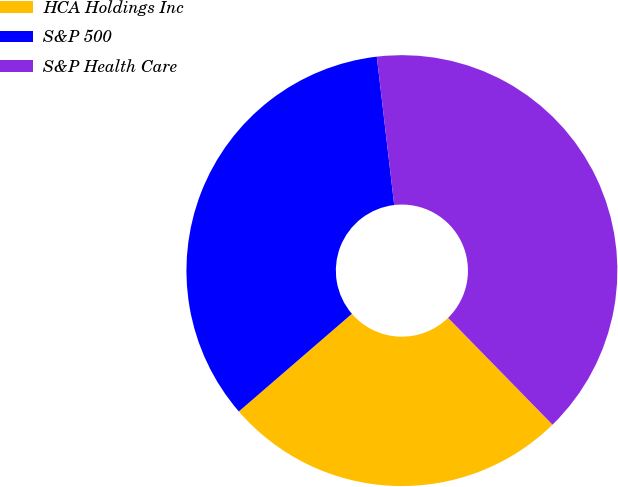Convert chart to OTSL. <chart><loc_0><loc_0><loc_500><loc_500><pie_chart><fcel>HCA Holdings Inc<fcel>S&P 500<fcel>S&P Health Care<nl><fcel>25.98%<fcel>34.48%<fcel>39.54%<nl></chart> 